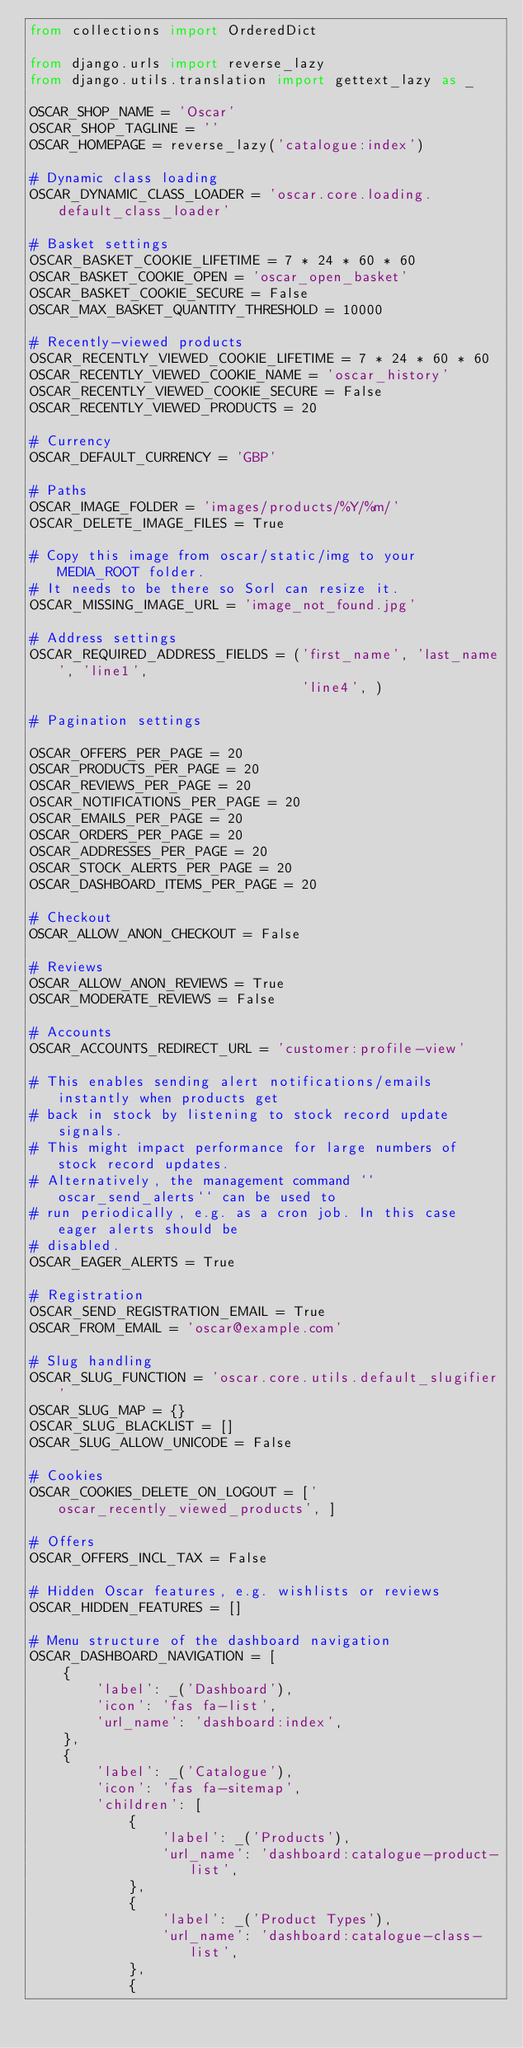<code> <loc_0><loc_0><loc_500><loc_500><_Python_>from collections import OrderedDict

from django.urls import reverse_lazy
from django.utils.translation import gettext_lazy as _

OSCAR_SHOP_NAME = 'Oscar'
OSCAR_SHOP_TAGLINE = ''
OSCAR_HOMEPAGE = reverse_lazy('catalogue:index')

# Dynamic class loading
OSCAR_DYNAMIC_CLASS_LOADER = 'oscar.core.loading.default_class_loader'

# Basket settings
OSCAR_BASKET_COOKIE_LIFETIME = 7 * 24 * 60 * 60
OSCAR_BASKET_COOKIE_OPEN = 'oscar_open_basket'
OSCAR_BASKET_COOKIE_SECURE = False
OSCAR_MAX_BASKET_QUANTITY_THRESHOLD = 10000

# Recently-viewed products
OSCAR_RECENTLY_VIEWED_COOKIE_LIFETIME = 7 * 24 * 60 * 60
OSCAR_RECENTLY_VIEWED_COOKIE_NAME = 'oscar_history'
OSCAR_RECENTLY_VIEWED_COOKIE_SECURE = False
OSCAR_RECENTLY_VIEWED_PRODUCTS = 20

# Currency
OSCAR_DEFAULT_CURRENCY = 'GBP'

# Paths
OSCAR_IMAGE_FOLDER = 'images/products/%Y/%m/'
OSCAR_DELETE_IMAGE_FILES = True

# Copy this image from oscar/static/img to your MEDIA_ROOT folder.
# It needs to be there so Sorl can resize it.
OSCAR_MISSING_IMAGE_URL = 'image_not_found.jpg'

# Address settings
OSCAR_REQUIRED_ADDRESS_FIELDS = ('first_name', 'last_name', 'line1',
                                 'line4', )

# Pagination settings

OSCAR_OFFERS_PER_PAGE = 20
OSCAR_PRODUCTS_PER_PAGE = 20
OSCAR_REVIEWS_PER_PAGE = 20
OSCAR_NOTIFICATIONS_PER_PAGE = 20
OSCAR_EMAILS_PER_PAGE = 20
OSCAR_ORDERS_PER_PAGE = 20
OSCAR_ADDRESSES_PER_PAGE = 20
OSCAR_STOCK_ALERTS_PER_PAGE = 20
OSCAR_DASHBOARD_ITEMS_PER_PAGE = 20

# Checkout
OSCAR_ALLOW_ANON_CHECKOUT = False

# Reviews
OSCAR_ALLOW_ANON_REVIEWS = True
OSCAR_MODERATE_REVIEWS = False

# Accounts
OSCAR_ACCOUNTS_REDIRECT_URL = 'customer:profile-view'

# This enables sending alert notifications/emails instantly when products get
# back in stock by listening to stock record update signals.
# This might impact performance for large numbers of stock record updates.
# Alternatively, the management command ``oscar_send_alerts`` can be used to
# run periodically, e.g. as a cron job. In this case eager alerts should be
# disabled.
OSCAR_EAGER_ALERTS = True

# Registration
OSCAR_SEND_REGISTRATION_EMAIL = True
OSCAR_FROM_EMAIL = 'oscar@example.com'

# Slug handling
OSCAR_SLUG_FUNCTION = 'oscar.core.utils.default_slugifier'
OSCAR_SLUG_MAP = {}
OSCAR_SLUG_BLACKLIST = []
OSCAR_SLUG_ALLOW_UNICODE = False

# Cookies
OSCAR_COOKIES_DELETE_ON_LOGOUT = ['oscar_recently_viewed_products', ]

# Offers
OSCAR_OFFERS_INCL_TAX = False

# Hidden Oscar features, e.g. wishlists or reviews
OSCAR_HIDDEN_FEATURES = []

# Menu structure of the dashboard navigation
OSCAR_DASHBOARD_NAVIGATION = [
    {
        'label': _('Dashboard'),
        'icon': 'fas fa-list',
        'url_name': 'dashboard:index',
    },
    {
        'label': _('Catalogue'),
        'icon': 'fas fa-sitemap',
        'children': [
            {
                'label': _('Products'),
                'url_name': 'dashboard:catalogue-product-list',
            },
            {
                'label': _('Product Types'),
                'url_name': 'dashboard:catalogue-class-list',
            },
            {</code> 